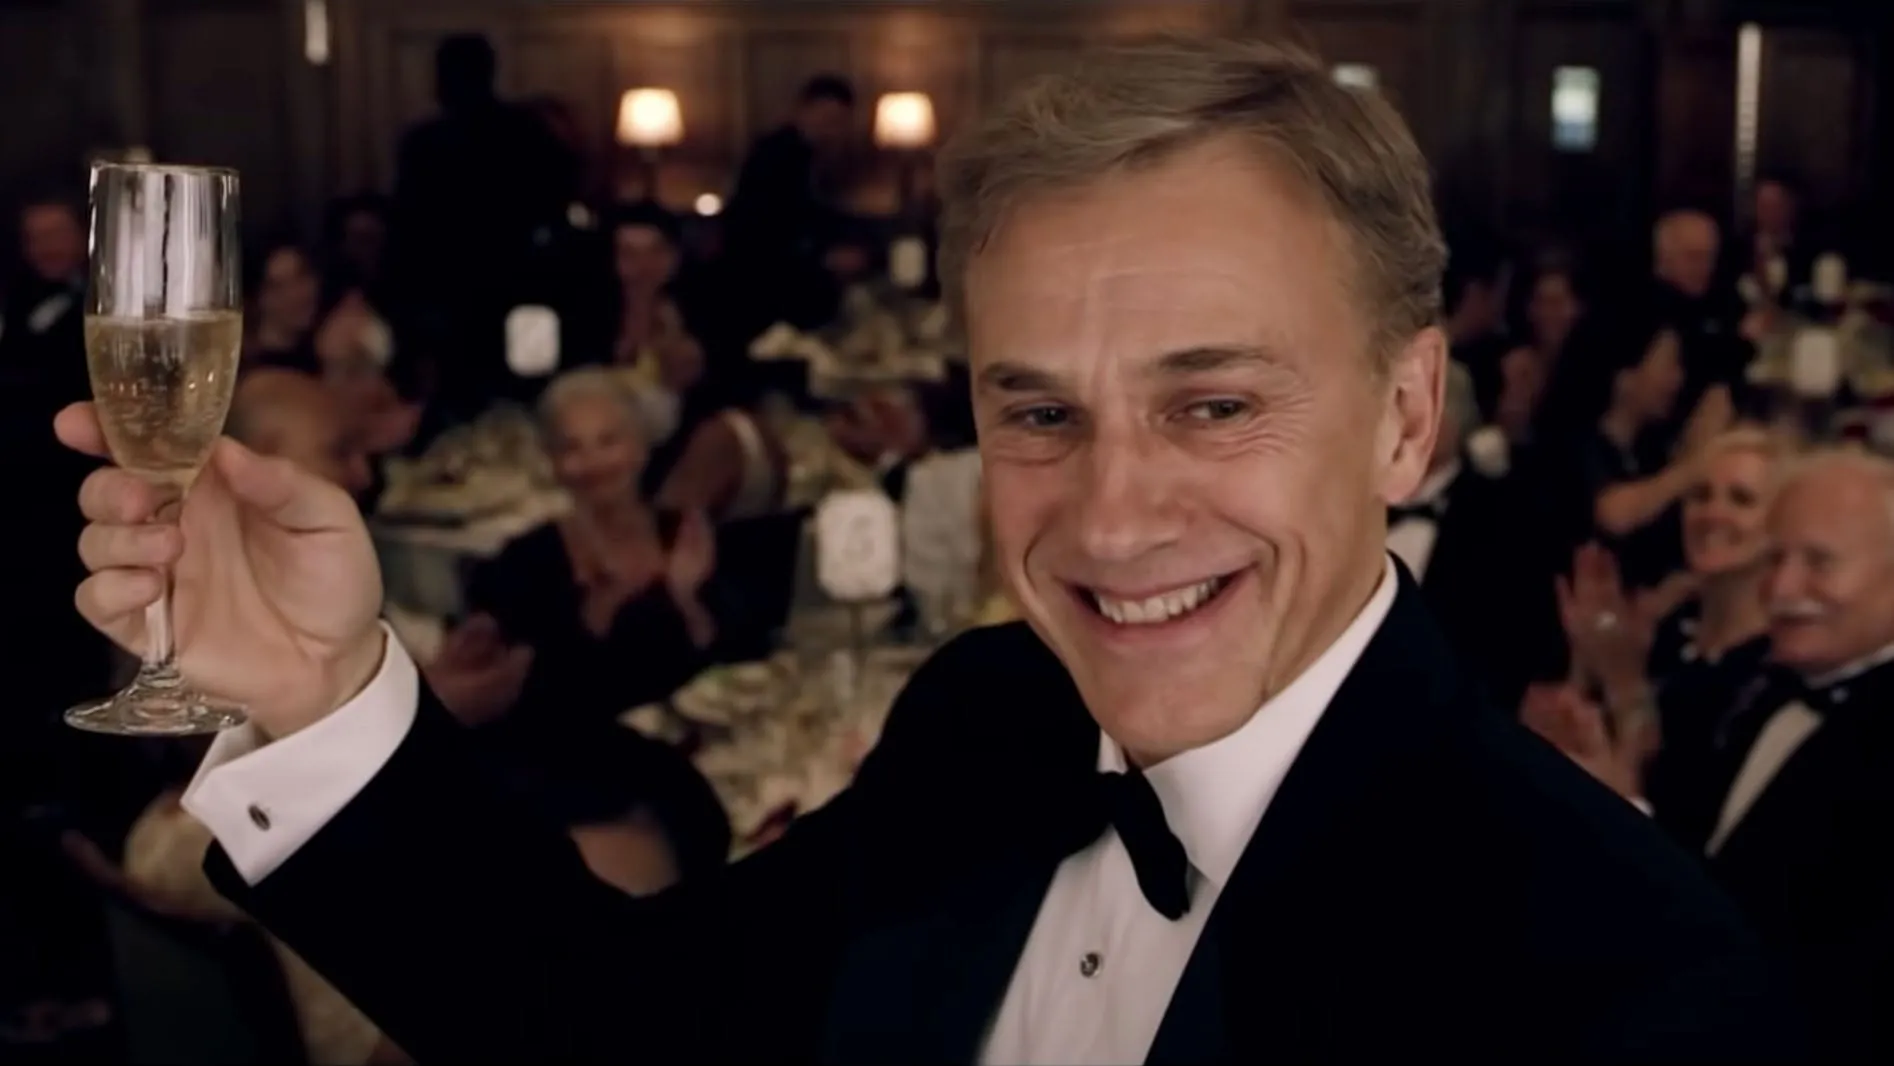What could be the main course served at this event? Given the grandeur of the setting, it's likely that the main course could be a gourmet dish such as a perfectly seared filet mignon served with a truffle-infused sauce, accompanied by a delicate lobster tail, roasted asparagus, and a rich, creamy garlic mashed potato. This elegant dish would perfectly align with the opulent atmosphere of the event. What kind of music would you expect to be playing in the background? Classical music or a smooth jazz ensemble would be fitting for this sophisticated setting, creating an elegant and relaxing background ambiance. Live music with a grand piano and string instruments could enhance the luxurious atmosphere, making the celebration feel even more special and refined. How do you think the guests are feeling in this image? The guests in this image appear to be in high spirits, evidenced by their smiles and applause. The celebratory atmosphere suggests a shared sense of joy and camaraderie, as they partake in what seems to be a significant and joyful event. They are likely feeling honored, happy, and part of a special occasion. 